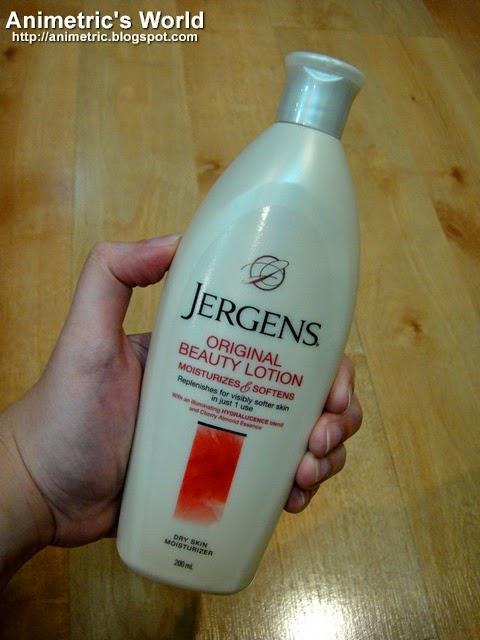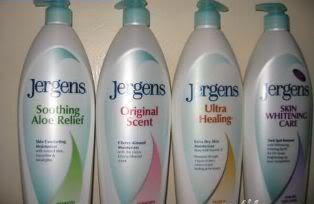The first image is the image on the left, the second image is the image on the right. Assess this claim about the two images: "No more than three lotion bottles are visible in the left image.". Correct or not? Answer yes or no. Yes. 